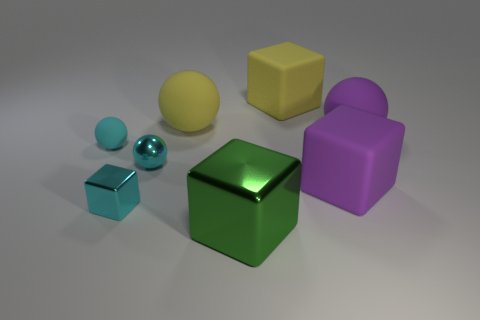How would you interpret the arrangement of these objects? The objects in the image appear to be deliberately placed, creating an aesthetically pleasing composition that could represent balance and diversity. Each object stands out with its unique size, shape, and color, possibly symbolizing variety and uniqueness. The positioning could be random or it may suggest a narrative, inviting viewers to ascribe their own meaning to the scene. 